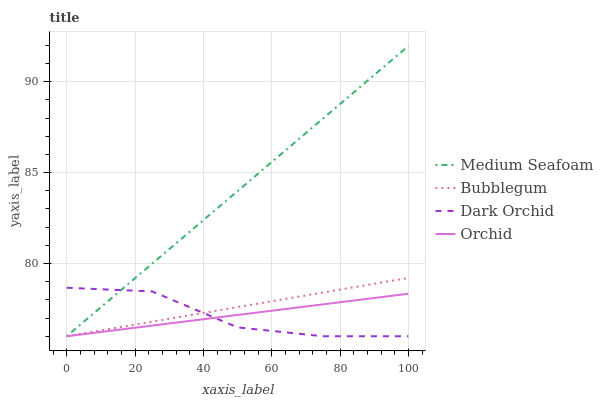Does Dark Orchid have the minimum area under the curve?
Answer yes or no. Yes. Does Medium Seafoam have the maximum area under the curve?
Answer yes or no. Yes. Does Bubblegum have the minimum area under the curve?
Answer yes or no. No. Does Bubblegum have the maximum area under the curve?
Answer yes or no. No. Is Bubblegum the smoothest?
Answer yes or no. Yes. Is Dark Orchid the roughest?
Answer yes or no. Yes. Is Medium Seafoam the smoothest?
Answer yes or no. No. Is Medium Seafoam the roughest?
Answer yes or no. No. Does Dark Orchid have the lowest value?
Answer yes or no. Yes. Does Medium Seafoam have the highest value?
Answer yes or no. Yes. Does Bubblegum have the highest value?
Answer yes or no. No. Does Medium Seafoam intersect Dark Orchid?
Answer yes or no. Yes. Is Medium Seafoam less than Dark Orchid?
Answer yes or no. No. Is Medium Seafoam greater than Dark Orchid?
Answer yes or no. No. 